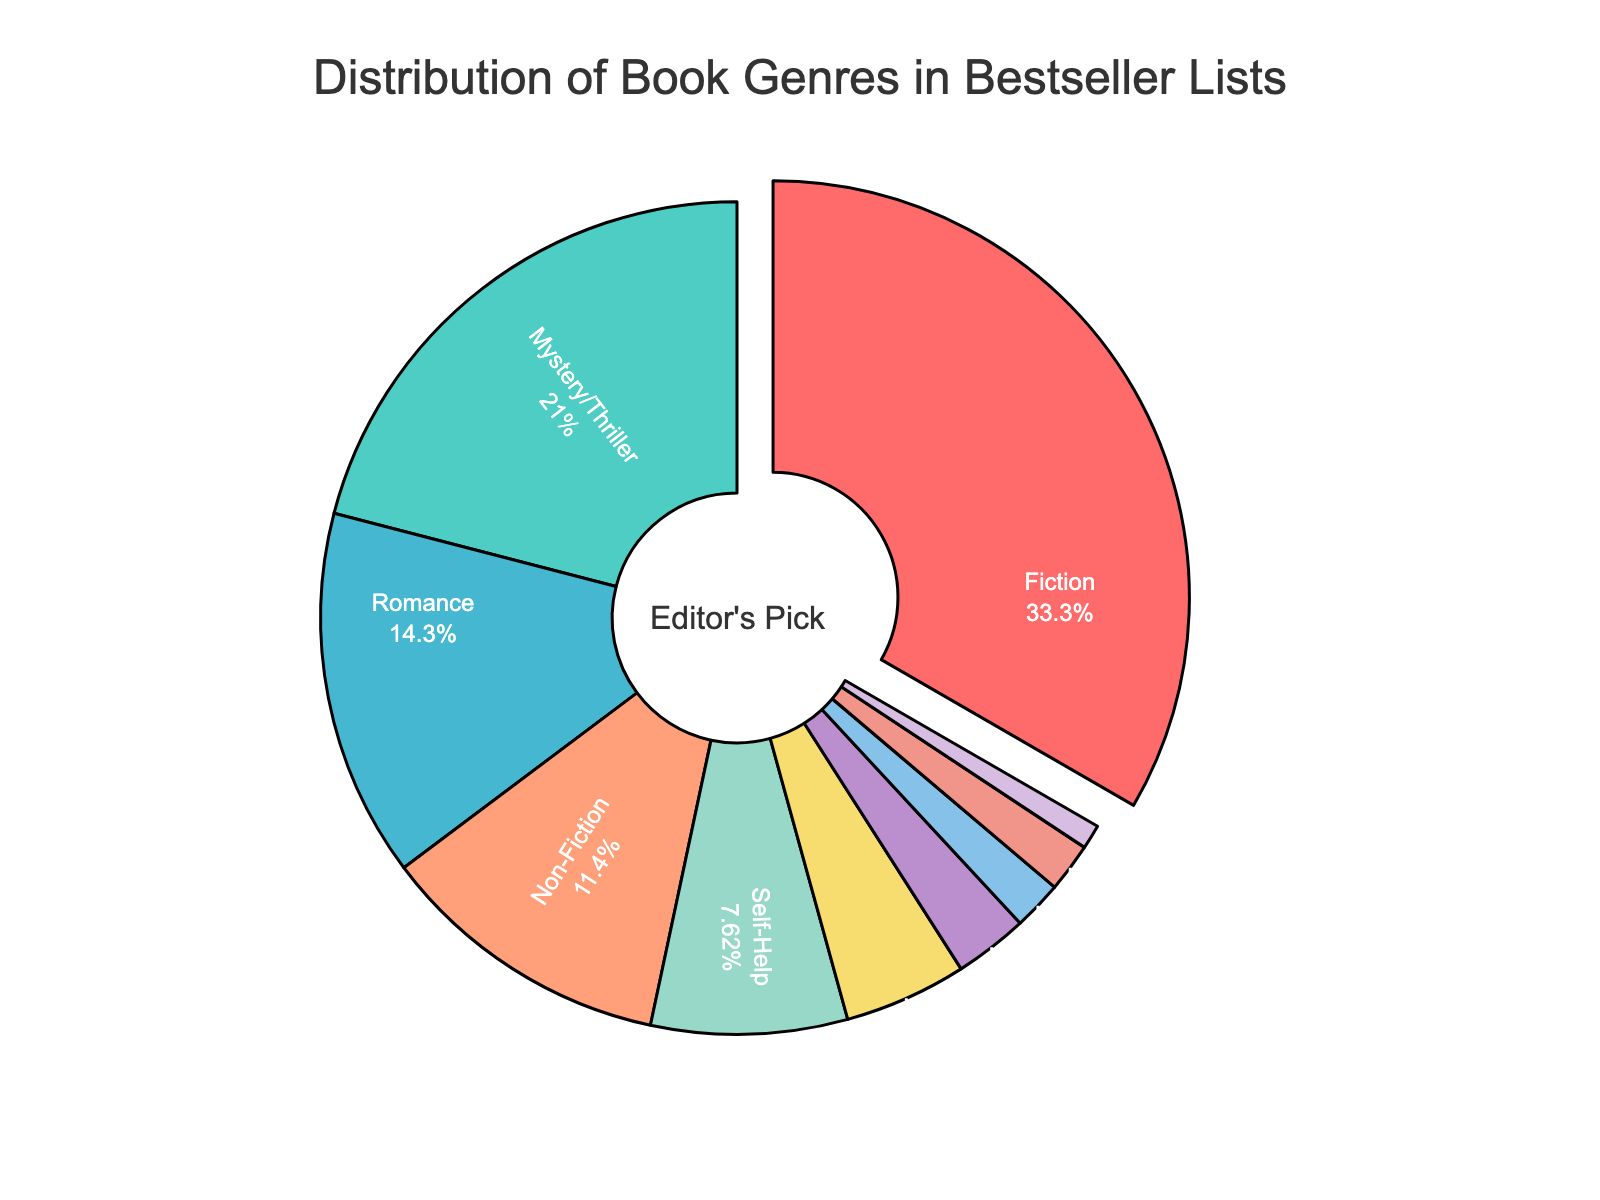Which genre appears most frequently in bestseller lists? Fiction has the highest percentage of 35%, making it the most frequent genre in bestseller lists.
Answer: Fiction How much higher is the percentage of Fiction books compared to Romance books? The percentage of Fiction books is 35% and Romance books is 15%. The difference is 35% - 15% = 20%.
Answer: 20% What is the combined percentage of Mystery/Thriller and Science Fiction/Fantasy genres? The percentage for Mystery/Thriller is 22% and for Science Fiction/Fantasy is 5%. Their combined percentage is 22% + 5% = 27%.
Answer: 27% If you combine the percentages of Non-Fiction, Self-Help, Biography/Memoir and Literary Fiction, does it exceed the percentage of Fiction books? The combined percentage of Non-Fiction (12%), Self-Help (8%), Biography/Memoir (2%) and Literary Fiction (2%) is 12% + 8% + 2% + 2% = 24%. This is less than the 35% for Fiction books.
Answer: No What is the visual cue that indicates which genre has the highest percentage in the pie chart? The slice of the pie chart representing Fiction is slightly pulled out from the rest of the chart, highlighting its higher percentage.
Answer: Pulled out slice Which genre has the smallest share in the bestseller lists? The genre with the smallest share is Young Adult at 1%.
Answer: Young Adult How does the percentage of Romance books compare to the combined percentage of Self-Help and Science Fiction/Fantasy? The percentage of Romance books is 15%, and the combined percentage of Self-Help (8%) and Science Fiction/Fantasy (5%) is 8% + 5% = 13%, which is less than 15%.
Answer: Romance is higher Is the percentage of Historical Fiction greater or smaller than the percentage of Self-Help books? Historical Fiction is 3% while Self-Help is 8%, so Historical Fiction is smaller.
Answer: Smaller What is the second most common genre on the bestseller lists? The Mystery/Thriller genre is the second most common with a percentage of 22%.
Answer: Mystery/Thriller By how much does Mystery/Thriller exceed Non-Fiction in terms of percentage? Mystery/Thriller is at 22% and Non-Fiction at 12%. The difference is 22% - 12% = 10%.
Answer: 10% 